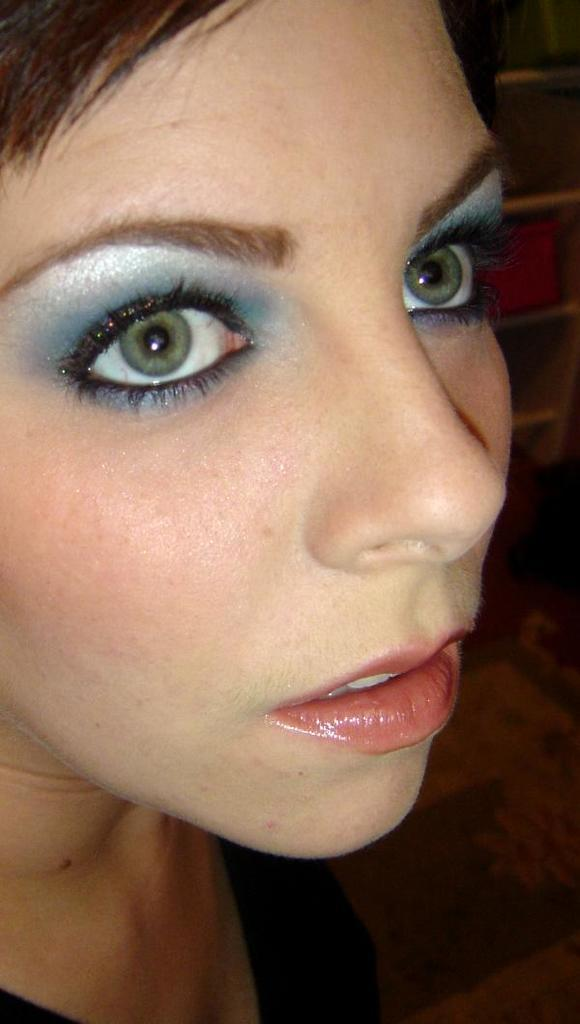Who or what is the main subject in the image? There is a person in the image. Can you describe the person's position in relation to the image? The person is in front. What can be seen on the right side of the image? There are objects on the right side of the image. What type of war is depicted in the image? There is no war depicted in the image; it features a person in front with objects on the right side. Can you describe the flight path of the person in the image? There is no flight path to describe, as the person is not depicted as flying or in motion. 